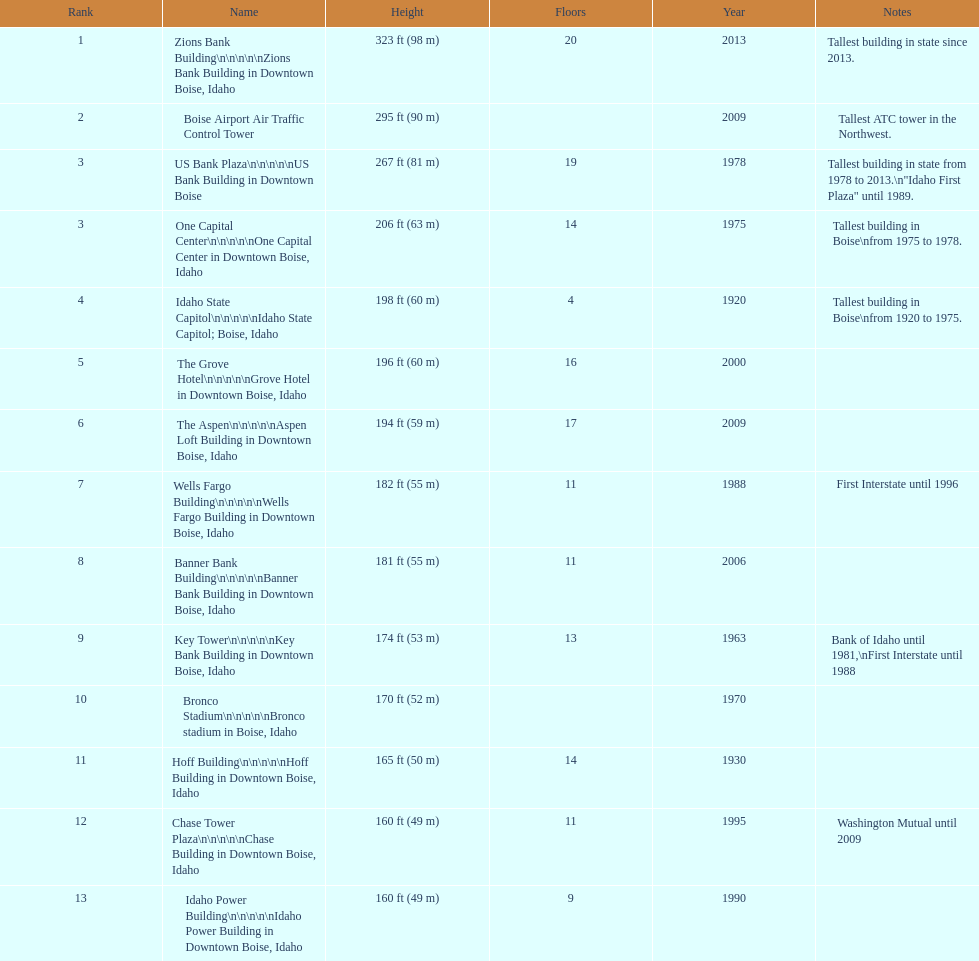What is the highest building in boise, idaho? Zions Bank Building Zions Bank Building in Downtown Boise, Idaho. 